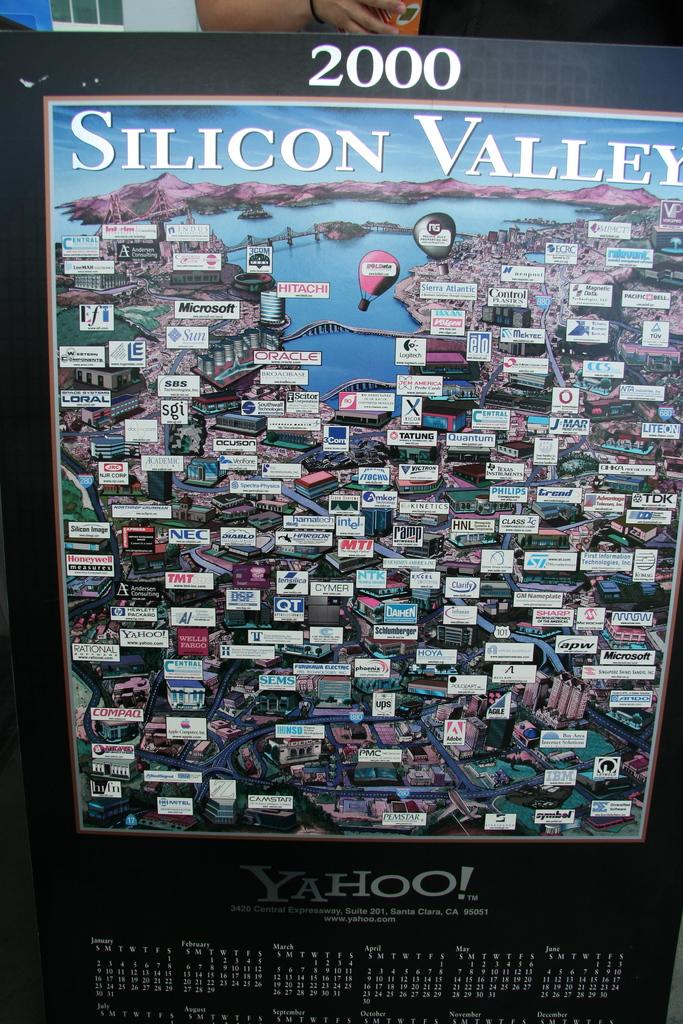Provide a one-sentence caption for the provided image. A laarge map of Silicon Valley with a calendar underneath advertising Yahoo!. 